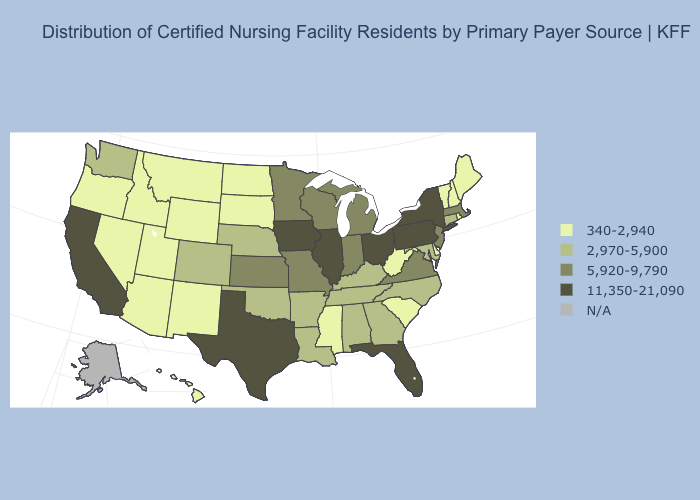Does California have the highest value in the USA?
Concise answer only. Yes. Name the states that have a value in the range N/A?
Answer briefly. Alaska. What is the lowest value in the Northeast?
Keep it brief. 340-2,940. What is the value of Delaware?
Give a very brief answer. 340-2,940. Does Kansas have the lowest value in the USA?
Keep it brief. No. Name the states that have a value in the range 2,970-5,900?
Be succinct. Alabama, Arkansas, Colorado, Connecticut, Georgia, Kentucky, Louisiana, Maryland, Nebraska, North Carolina, Oklahoma, Tennessee, Washington. What is the lowest value in states that border Massachusetts?
Concise answer only. 340-2,940. Does the map have missing data?
Give a very brief answer. Yes. What is the lowest value in the West?
Answer briefly. 340-2,940. Name the states that have a value in the range N/A?
Answer briefly. Alaska. Name the states that have a value in the range 5,920-9,790?
Give a very brief answer. Indiana, Kansas, Massachusetts, Michigan, Minnesota, Missouri, New Jersey, Virginia, Wisconsin. 